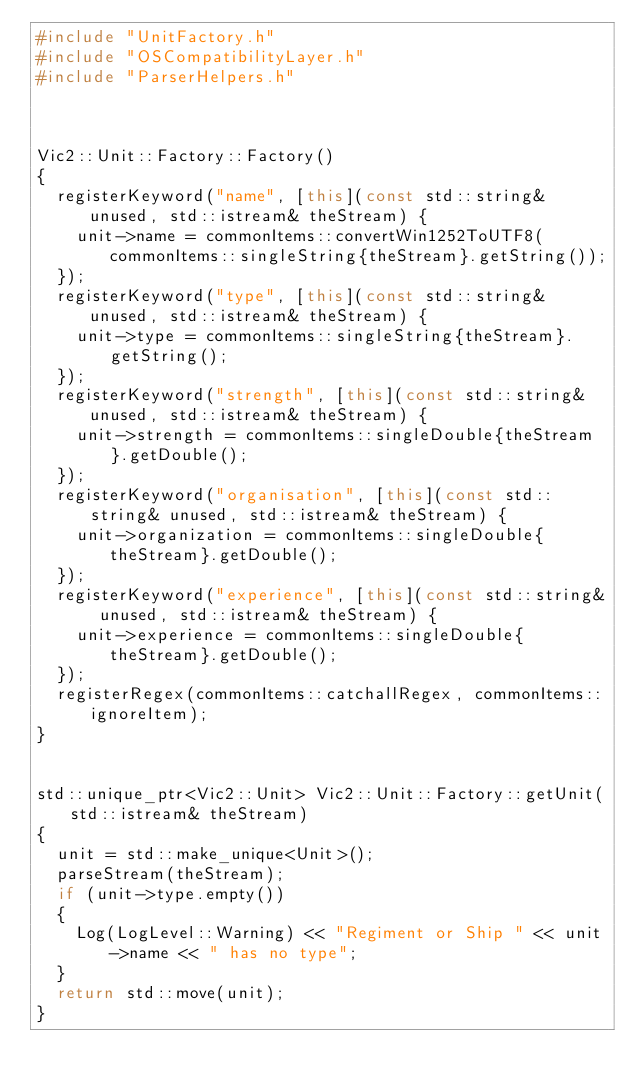Convert code to text. <code><loc_0><loc_0><loc_500><loc_500><_C++_>#include "UnitFactory.h"
#include "OSCompatibilityLayer.h"
#include "ParserHelpers.h"



Vic2::Unit::Factory::Factory()
{
	registerKeyword("name", [this](const std::string& unused, std::istream& theStream) {
		unit->name = commonItems::convertWin1252ToUTF8(commonItems::singleString{theStream}.getString());
	});
	registerKeyword("type", [this](const std::string& unused, std::istream& theStream) {
		unit->type = commonItems::singleString{theStream}.getString();
	});
	registerKeyword("strength", [this](const std::string& unused, std::istream& theStream) {
		unit->strength = commonItems::singleDouble{theStream}.getDouble();
	});
	registerKeyword("organisation", [this](const std::string& unused, std::istream& theStream) {
		unit->organization = commonItems::singleDouble{theStream}.getDouble();
	});
	registerKeyword("experience", [this](const std::string& unused, std::istream& theStream) {
		unit->experience = commonItems::singleDouble{theStream}.getDouble();
	});
	registerRegex(commonItems::catchallRegex, commonItems::ignoreItem);
}


std::unique_ptr<Vic2::Unit> Vic2::Unit::Factory::getUnit(std::istream& theStream)
{
	unit = std::make_unique<Unit>();
	parseStream(theStream);
	if (unit->type.empty())
	{
		Log(LogLevel::Warning) << "Regiment or Ship " << unit->name << " has no type";
	}
	return std::move(unit);
}</code> 